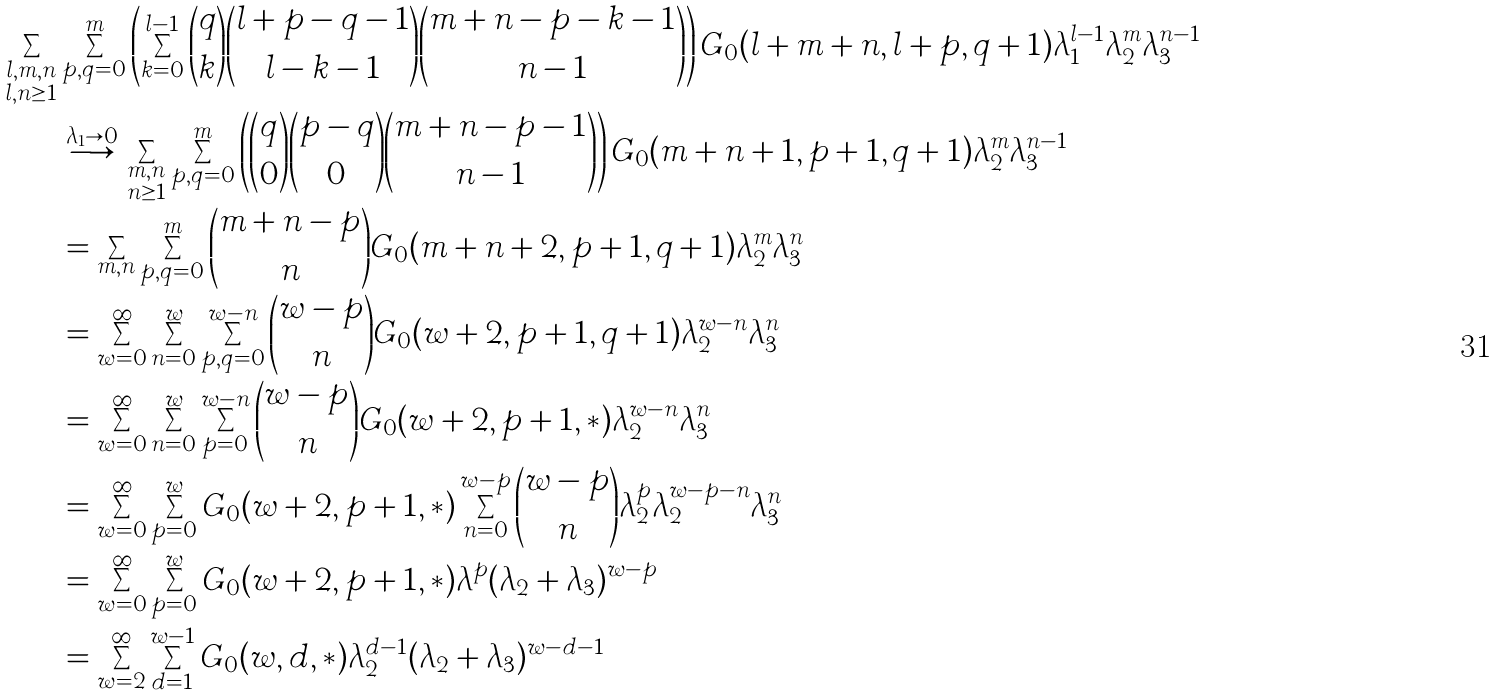Convert formula to latex. <formula><loc_0><loc_0><loc_500><loc_500>\sum _ { \substack { l , m , n \\ l , n \geq 1 } } & \sum _ { p , q = 0 } ^ { m } \left ( \sum _ { k = 0 } ^ { l - 1 } \binom { q } { k } \binom { l + p - q - 1 } { l - k - 1 } \binom { m + n - p - k - 1 } { n - 1 } \right ) G _ { 0 } ( l + m + n , l + p , q + 1 ) \lambda _ { 1 } ^ { l - 1 } \lambda _ { 2 } ^ { m } \lambda _ { 3 } ^ { n - 1 } \\ & \overset { \lambda _ { 1 } \to 0 } { \longrightarrow } \sum _ { \substack { m , n \\ n \geq 1 } } \sum _ { p , q = 0 } ^ { m } \left ( \binom { q } { 0 } \binom { p - q } { 0 } \binom { m + n - p - 1 } { n - 1 } \right ) G _ { 0 } ( m + n + 1 , p + 1 , q + 1 ) \lambda _ { 2 } ^ { m } \lambda _ { 3 } ^ { n - 1 } \\ & = \sum _ { m , n } \sum _ { p , q = 0 } ^ { m } \binom { m + n - p } { n } G _ { 0 } ( m + n + 2 , p + 1 , q + 1 ) \lambda _ { 2 } ^ { m } \lambda _ { 3 } ^ { n } \\ & = \sum _ { w = 0 } ^ { \infty } \sum _ { n = 0 } ^ { w } \sum _ { p , q = 0 } ^ { w - n } \binom { w - p } { n } G _ { 0 } ( w + 2 , p + 1 , q + 1 ) \lambda _ { 2 } ^ { w - n } \lambda _ { 3 } ^ { n } \\ & = \sum _ { w = 0 } ^ { \infty } \sum _ { n = 0 } ^ { w } \sum _ { p = 0 } ^ { w - n } \binom { w - p } { n } G _ { 0 } ( w + 2 , p + 1 , * ) \lambda _ { 2 } ^ { w - n } \lambda _ { 3 } ^ { n } \\ & = \sum _ { w = 0 } ^ { \infty } \sum _ { p = 0 } ^ { w } G _ { 0 } ( w + 2 , p + 1 , * ) \sum _ { n = 0 } ^ { w - p } \binom { w - p } { n } \lambda _ { 2 } ^ { p } \lambda _ { 2 } ^ { w - p - n } \lambda _ { 3 } ^ { n } \\ & = \sum _ { w = 0 } ^ { \infty } \sum _ { p = 0 } ^ { w } G _ { 0 } ( w + 2 , p + 1 , * ) \lambda ^ { p } ( \lambda _ { 2 } + \lambda _ { 3 } ) ^ { w - p } \\ & = \sum _ { w = 2 } ^ { \infty } \sum _ { d = 1 } ^ { w - 1 } G _ { 0 } ( w , d , * ) \lambda _ { 2 } ^ { d - 1 } ( \lambda _ { 2 } + \lambda _ { 3 } ) ^ { w - d - 1 }</formula> 